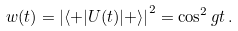<formula> <loc_0><loc_0><loc_500><loc_500>w ( t ) = \left | \langle + | U ( t ) | + \rangle \right | ^ { 2 } = \cos ^ { 2 } g t \, .</formula> 